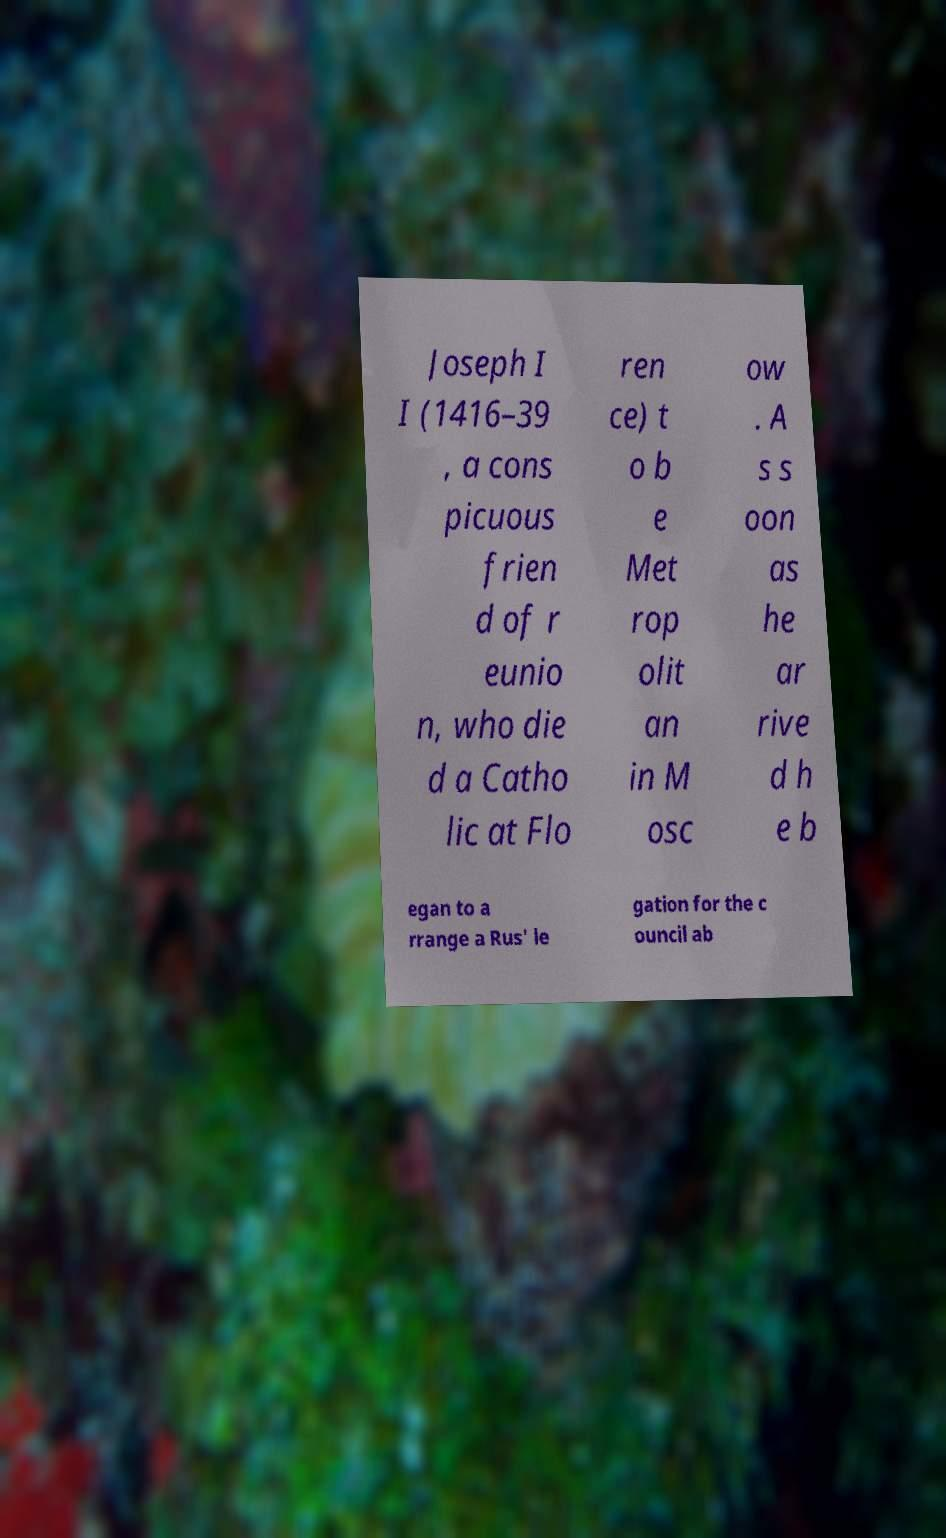What messages or text are displayed in this image? I need them in a readable, typed format. Joseph I I (1416–39 , a cons picuous frien d of r eunio n, who die d a Catho lic at Flo ren ce) t o b e Met rop olit an in M osc ow . A s s oon as he ar rive d h e b egan to a rrange a Rus' le gation for the c ouncil ab 